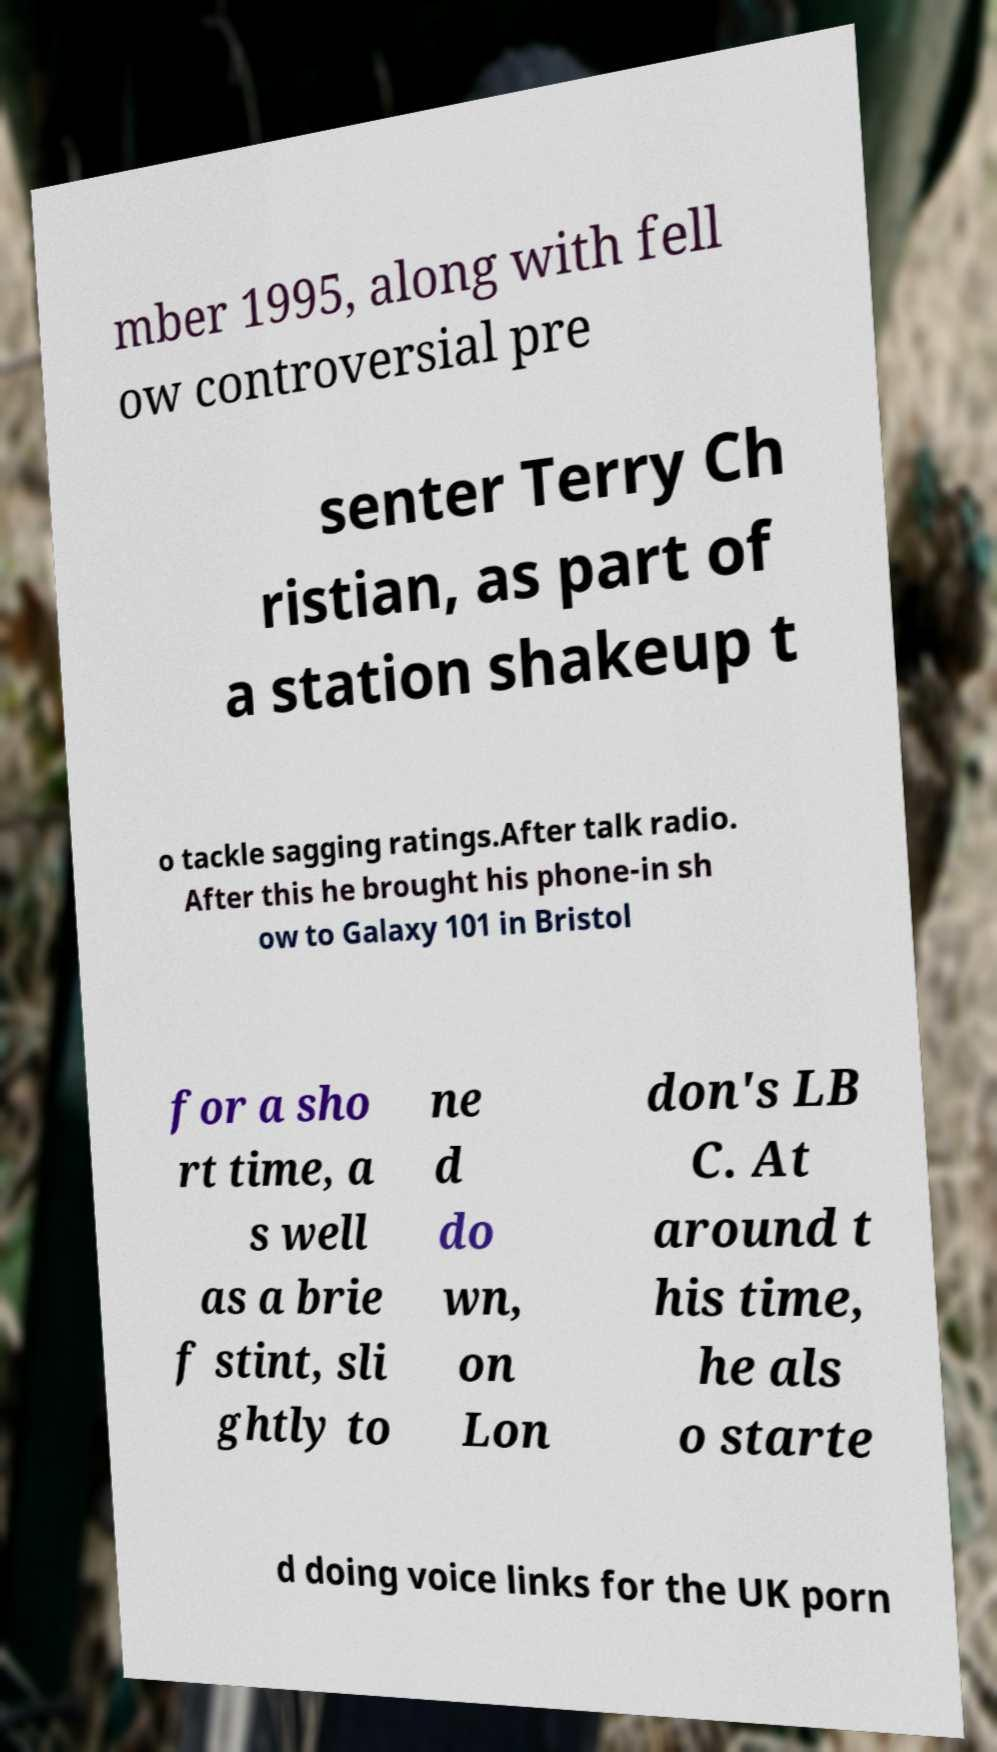Could you extract and type out the text from this image? mber 1995, along with fell ow controversial pre senter Terry Ch ristian, as part of a station shakeup t o tackle sagging ratings.After talk radio. After this he brought his phone-in sh ow to Galaxy 101 in Bristol for a sho rt time, a s well as a brie f stint, sli ghtly to ne d do wn, on Lon don's LB C. At around t his time, he als o starte d doing voice links for the UK porn 